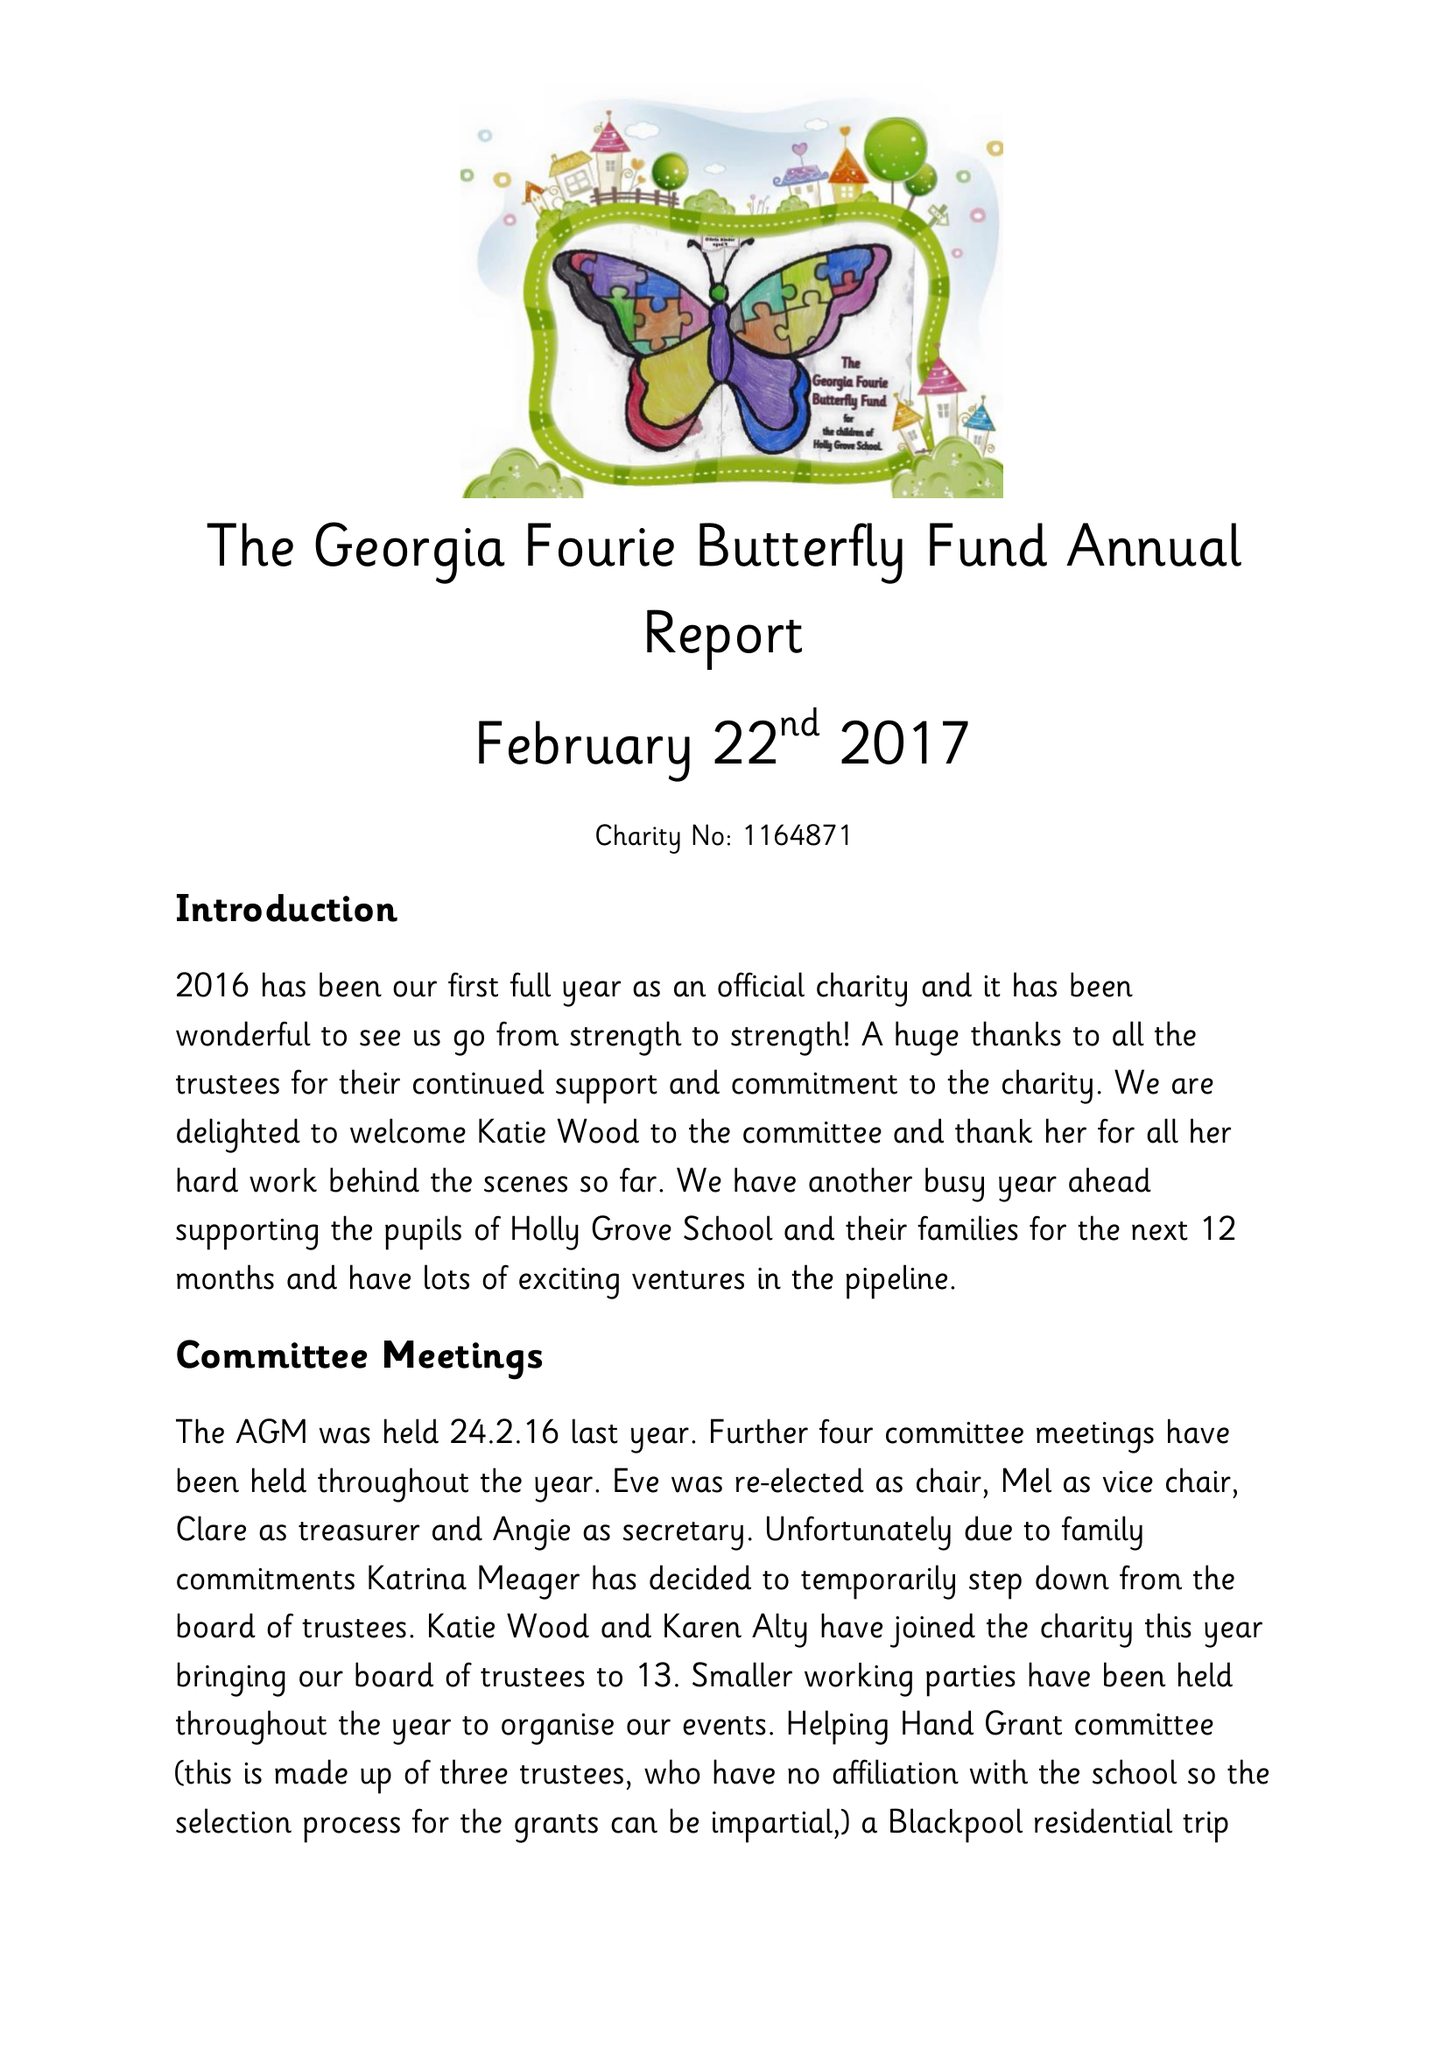What is the value for the address__postcode?
Answer the question using a single word or phrase. BB10 1JD 